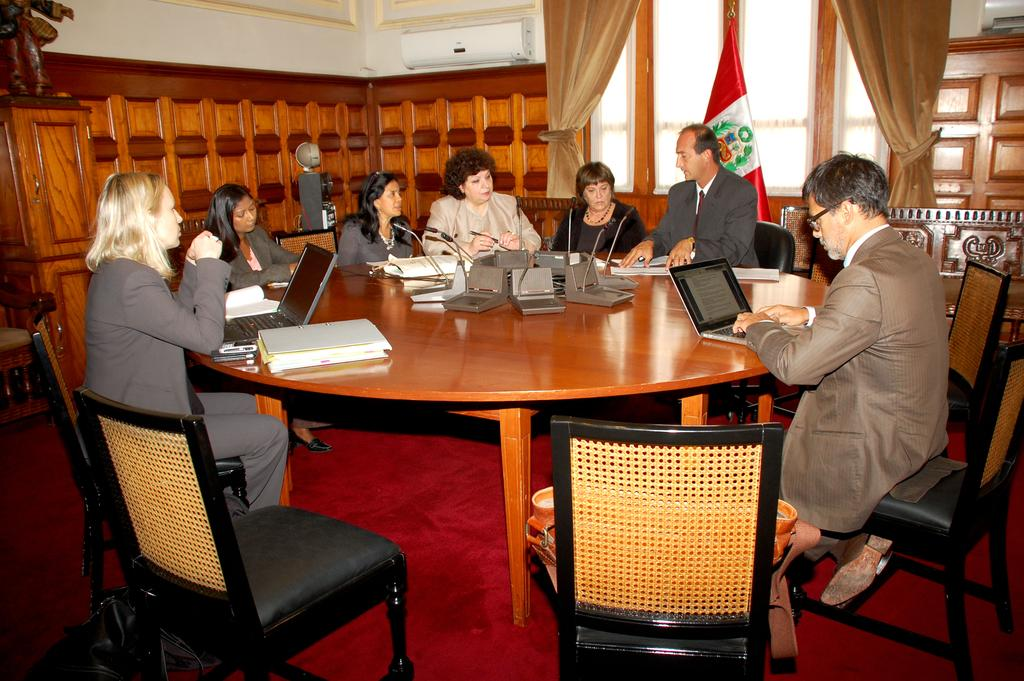How many people are present in the image? There are seven people in the image. How are the people arranged in the image? The people are sitting in a circular manner. What furniture can be seen in the image? There is a chair and a table in the image. What type of system is present in the image? There is a system (possibly a computer or audio system) in the image. What additional object can be seen in the image? There is a flag in the image. Can you describe the jellyfish swimming in the image? There are no jellyfish present in the image. What example can be seen in the image? The image itself is an example, but there is no specific example within the image. 